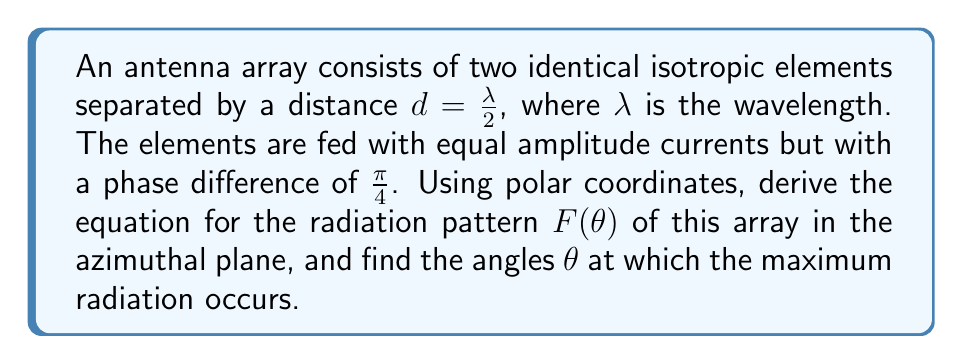Could you help me with this problem? To solve this problem, we'll follow these steps:

1. Recall the general equation for the array factor of a two-element array:
   $$F(\theta) = 2\cos(\frac{1}{2}[\psi + \beta d\cos\theta])$$
   where $\psi$ is the phase difference between elements, $\beta = \frac{2\pi}{\lambda}$ is the wave number, $d$ is the element spacing, and $\theta$ is the angle from the array axis.

2. Substitute the given values:
   $\psi = \frac{\pi}{4}$
   $d = \frac{\lambda}{2}$
   $\beta d = \frac{2\pi}{\lambda} \cdot \frac{\lambda}{2} = \pi$

3. The array factor becomes:
   $$F(\theta) = 2\cos(\frac{1}{2}[\frac{\pi}{4} + \pi\cos\theta])$$

4. To find the maximum radiation angles, we need to find where the cosine term is maximum (i.e., equals 1). This occurs when:
   $$\frac{1}{2}[\frac{\pi}{4} + \pi\cos\theta] = 0 \text{ or } \pi$$

5. Solve for $\theta$:
   $$\frac{\pi}{4} + \pi\cos\theta = 0 \text{ or } 2\pi$$
   $$\cos\theta = -\frac{1}{4} \text{ or } \frac{7}{4}$$

6. The second solution is not possible as cosine is bounded between -1 and 1. For the first solution:
   $$\theta = \arccos(-\frac{1}{4}) \approx 1.82 \text{ radians } \approx 104.5°$$

7. Due to the symmetry of the array, there will be another maximum at:
   $$\theta = 2\pi - 1.82 \approx 4.46 \text{ radians } \approx 255.5°$$
Answer: The radiation pattern of the antenna array is given by:
$$F(\theta) = 2\cos(\frac{1}{2}[\frac{\pi}{4} + \pi\cos\theta])$$
The maximum radiation occurs at angles $\theta \approx 104.5°$ and $\theta \approx 255.5°$ in the azimuthal plane. 